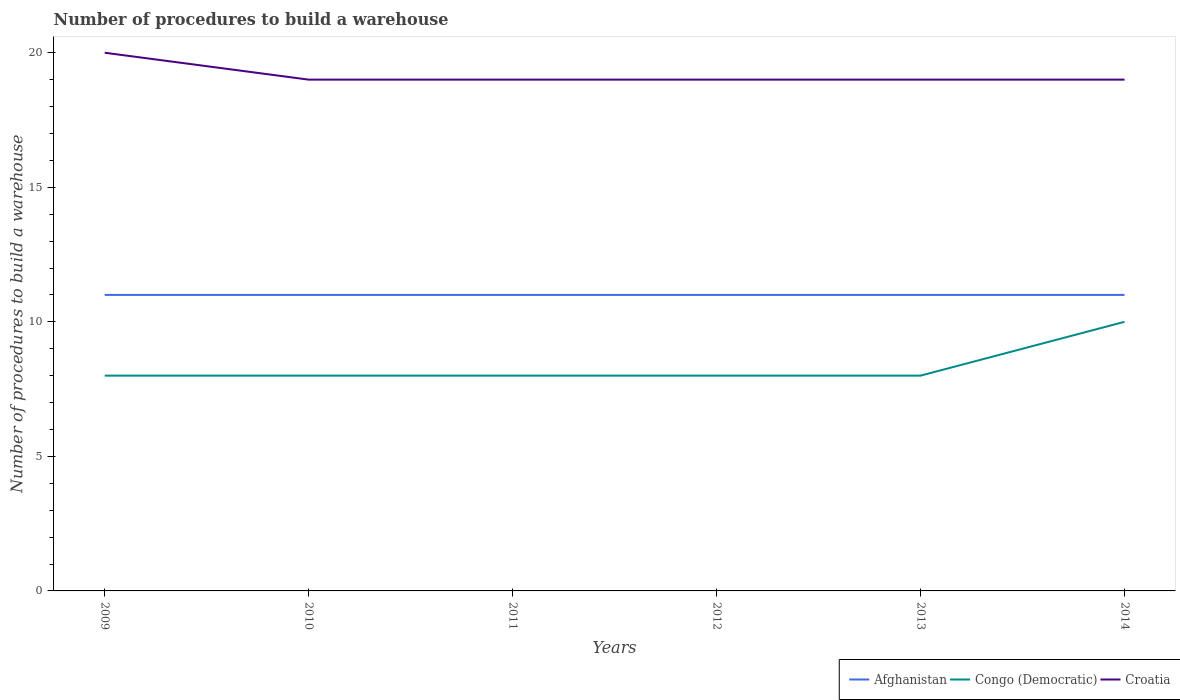How many different coloured lines are there?
Your answer should be compact. 3. Is the number of lines equal to the number of legend labels?
Keep it short and to the point. Yes. Across all years, what is the maximum number of procedures to build a warehouse in in Croatia?
Offer a terse response. 19. What is the difference between the highest and the second highest number of procedures to build a warehouse in in Croatia?
Your answer should be very brief. 1. How many lines are there?
Provide a succinct answer. 3. Where does the legend appear in the graph?
Offer a very short reply. Bottom right. How are the legend labels stacked?
Your answer should be compact. Horizontal. What is the title of the graph?
Give a very brief answer. Number of procedures to build a warehouse. Does "Low income" appear as one of the legend labels in the graph?
Offer a terse response. No. What is the label or title of the Y-axis?
Provide a short and direct response. Number of procedures to build a warehouse. What is the Number of procedures to build a warehouse of Afghanistan in 2009?
Give a very brief answer. 11. What is the Number of procedures to build a warehouse of Congo (Democratic) in 2009?
Give a very brief answer. 8. What is the Number of procedures to build a warehouse in Croatia in 2009?
Keep it short and to the point. 20. What is the Number of procedures to build a warehouse in Afghanistan in 2010?
Offer a very short reply. 11. What is the Number of procedures to build a warehouse in Croatia in 2010?
Make the answer very short. 19. What is the Number of procedures to build a warehouse in Croatia in 2011?
Provide a short and direct response. 19. What is the Number of procedures to build a warehouse of Afghanistan in 2012?
Give a very brief answer. 11. What is the Number of procedures to build a warehouse in Croatia in 2013?
Keep it short and to the point. 19. Across all years, what is the minimum Number of procedures to build a warehouse of Afghanistan?
Your answer should be compact. 11. Across all years, what is the minimum Number of procedures to build a warehouse of Congo (Democratic)?
Give a very brief answer. 8. What is the total Number of procedures to build a warehouse of Congo (Democratic) in the graph?
Your answer should be very brief. 50. What is the total Number of procedures to build a warehouse of Croatia in the graph?
Make the answer very short. 115. What is the difference between the Number of procedures to build a warehouse in Afghanistan in 2009 and that in 2010?
Your response must be concise. 0. What is the difference between the Number of procedures to build a warehouse of Afghanistan in 2009 and that in 2011?
Your answer should be very brief. 0. What is the difference between the Number of procedures to build a warehouse in Congo (Democratic) in 2009 and that in 2011?
Offer a very short reply. 0. What is the difference between the Number of procedures to build a warehouse in Croatia in 2009 and that in 2011?
Keep it short and to the point. 1. What is the difference between the Number of procedures to build a warehouse of Afghanistan in 2009 and that in 2012?
Your answer should be very brief. 0. What is the difference between the Number of procedures to build a warehouse of Afghanistan in 2009 and that in 2013?
Your answer should be very brief. 0. What is the difference between the Number of procedures to build a warehouse in Afghanistan in 2009 and that in 2014?
Your answer should be compact. 0. What is the difference between the Number of procedures to build a warehouse in Afghanistan in 2010 and that in 2012?
Give a very brief answer. 0. What is the difference between the Number of procedures to build a warehouse of Croatia in 2010 and that in 2013?
Give a very brief answer. 0. What is the difference between the Number of procedures to build a warehouse in Congo (Democratic) in 2010 and that in 2014?
Provide a short and direct response. -2. What is the difference between the Number of procedures to build a warehouse of Croatia in 2010 and that in 2014?
Your answer should be very brief. 0. What is the difference between the Number of procedures to build a warehouse in Croatia in 2011 and that in 2012?
Your response must be concise. 0. What is the difference between the Number of procedures to build a warehouse of Afghanistan in 2011 and that in 2014?
Your response must be concise. 0. What is the difference between the Number of procedures to build a warehouse in Afghanistan in 2012 and that in 2013?
Your answer should be compact. 0. What is the difference between the Number of procedures to build a warehouse in Congo (Democratic) in 2012 and that in 2013?
Your response must be concise. 0. What is the difference between the Number of procedures to build a warehouse of Afghanistan in 2013 and that in 2014?
Provide a succinct answer. 0. What is the difference between the Number of procedures to build a warehouse of Congo (Democratic) in 2013 and that in 2014?
Your answer should be compact. -2. What is the difference between the Number of procedures to build a warehouse of Afghanistan in 2009 and the Number of procedures to build a warehouse of Congo (Democratic) in 2010?
Offer a very short reply. 3. What is the difference between the Number of procedures to build a warehouse in Afghanistan in 2009 and the Number of procedures to build a warehouse in Croatia in 2010?
Offer a very short reply. -8. What is the difference between the Number of procedures to build a warehouse of Afghanistan in 2009 and the Number of procedures to build a warehouse of Croatia in 2011?
Your answer should be compact. -8. What is the difference between the Number of procedures to build a warehouse of Congo (Democratic) in 2009 and the Number of procedures to build a warehouse of Croatia in 2011?
Your answer should be compact. -11. What is the difference between the Number of procedures to build a warehouse in Afghanistan in 2009 and the Number of procedures to build a warehouse in Congo (Democratic) in 2013?
Provide a short and direct response. 3. What is the difference between the Number of procedures to build a warehouse of Afghanistan in 2009 and the Number of procedures to build a warehouse of Croatia in 2013?
Give a very brief answer. -8. What is the difference between the Number of procedures to build a warehouse in Afghanistan in 2010 and the Number of procedures to build a warehouse in Congo (Democratic) in 2011?
Provide a short and direct response. 3. What is the difference between the Number of procedures to build a warehouse in Afghanistan in 2010 and the Number of procedures to build a warehouse in Congo (Democratic) in 2012?
Provide a succinct answer. 3. What is the difference between the Number of procedures to build a warehouse of Afghanistan in 2010 and the Number of procedures to build a warehouse of Croatia in 2012?
Your answer should be compact. -8. What is the difference between the Number of procedures to build a warehouse in Afghanistan in 2010 and the Number of procedures to build a warehouse in Croatia in 2013?
Provide a succinct answer. -8. What is the difference between the Number of procedures to build a warehouse of Afghanistan in 2010 and the Number of procedures to build a warehouse of Congo (Democratic) in 2014?
Keep it short and to the point. 1. What is the difference between the Number of procedures to build a warehouse of Afghanistan in 2010 and the Number of procedures to build a warehouse of Croatia in 2014?
Your answer should be compact. -8. What is the difference between the Number of procedures to build a warehouse in Congo (Democratic) in 2010 and the Number of procedures to build a warehouse in Croatia in 2014?
Offer a very short reply. -11. What is the difference between the Number of procedures to build a warehouse in Congo (Democratic) in 2011 and the Number of procedures to build a warehouse in Croatia in 2012?
Give a very brief answer. -11. What is the difference between the Number of procedures to build a warehouse of Afghanistan in 2011 and the Number of procedures to build a warehouse of Croatia in 2013?
Provide a short and direct response. -8. What is the difference between the Number of procedures to build a warehouse of Congo (Democratic) in 2011 and the Number of procedures to build a warehouse of Croatia in 2013?
Make the answer very short. -11. What is the difference between the Number of procedures to build a warehouse of Congo (Democratic) in 2011 and the Number of procedures to build a warehouse of Croatia in 2014?
Offer a terse response. -11. What is the difference between the Number of procedures to build a warehouse of Afghanistan in 2012 and the Number of procedures to build a warehouse of Congo (Democratic) in 2013?
Keep it short and to the point. 3. What is the difference between the Number of procedures to build a warehouse of Afghanistan in 2012 and the Number of procedures to build a warehouse of Croatia in 2013?
Offer a very short reply. -8. What is the difference between the Number of procedures to build a warehouse in Congo (Democratic) in 2012 and the Number of procedures to build a warehouse in Croatia in 2013?
Ensure brevity in your answer.  -11. What is the difference between the Number of procedures to build a warehouse of Afghanistan in 2012 and the Number of procedures to build a warehouse of Congo (Democratic) in 2014?
Offer a terse response. 1. What is the difference between the Number of procedures to build a warehouse in Afghanistan in 2012 and the Number of procedures to build a warehouse in Croatia in 2014?
Ensure brevity in your answer.  -8. What is the difference between the Number of procedures to build a warehouse of Afghanistan in 2013 and the Number of procedures to build a warehouse of Congo (Democratic) in 2014?
Offer a very short reply. 1. What is the average Number of procedures to build a warehouse of Congo (Democratic) per year?
Ensure brevity in your answer.  8.33. What is the average Number of procedures to build a warehouse in Croatia per year?
Your response must be concise. 19.17. In the year 2009, what is the difference between the Number of procedures to build a warehouse in Afghanistan and Number of procedures to build a warehouse in Congo (Democratic)?
Provide a succinct answer. 3. In the year 2009, what is the difference between the Number of procedures to build a warehouse of Congo (Democratic) and Number of procedures to build a warehouse of Croatia?
Make the answer very short. -12. In the year 2010, what is the difference between the Number of procedures to build a warehouse in Afghanistan and Number of procedures to build a warehouse in Croatia?
Make the answer very short. -8. In the year 2011, what is the difference between the Number of procedures to build a warehouse of Afghanistan and Number of procedures to build a warehouse of Congo (Democratic)?
Keep it short and to the point. 3. In the year 2011, what is the difference between the Number of procedures to build a warehouse in Afghanistan and Number of procedures to build a warehouse in Croatia?
Offer a terse response. -8. In the year 2011, what is the difference between the Number of procedures to build a warehouse of Congo (Democratic) and Number of procedures to build a warehouse of Croatia?
Provide a succinct answer. -11. In the year 2012, what is the difference between the Number of procedures to build a warehouse in Afghanistan and Number of procedures to build a warehouse in Congo (Democratic)?
Offer a terse response. 3. In the year 2013, what is the difference between the Number of procedures to build a warehouse of Congo (Democratic) and Number of procedures to build a warehouse of Croatia?
Provide a succinct answer. -11. In the year 2014, what is the difference between the Number of procedures to build a warehouse in Congo (Democratic) and Number of procedures to build a warehouse in Croatia?
Keep it short and to the point. -9. What is the ratio of the Number of procedures to build a warehouse in Afghanistan in 2009 to that in 2010?
Your answer should be very brief. 1. What is the ratio of the Number of procedures to build a warehouse of Croatia in 2009 to that in 2010?
Your answer should be compact. 1.05. What is the ratio of the Number of procedures to build a warehouse of Croatia in 2009 to that in 2011?
Offer a terse response. 1.05. What is the ratio of the Number of procedures to build a warehouse in Congo (Democratic) in 2009 to that in 2012?
Your answer should be very brief. 1. What is the ratio of the Number of procedures to build a warehouse of Croatia in 2009 to that in 2012?
Provide a short and direct response. 1.05. What is the ratio of the Number of procedures to build a warehouse in Afghanistan in 2009 to that in 2013?
Give a very brief answer. 1. What is the ratio of the Number of procedures to build a warehouse of Congo (Democratic) in 2009 to that in 2013?
Offer a terse response. 1. What is the ratio of the Number of procedures to build a warehouse in Croatia in 2009 to that in 2013?
Your answer should be very brief. 1.05. What is the ratio of the Number of procedures to build a warehouse in Croatia in 2009 to that in 2014?
Make the answer very short. 1.05. What is the ratio of the Number of procedures to build a warehouse in Afghanistan in 2010 to that in 2011?
Your response must be concise. 1. What is the ratio of the Number of procedures to build a warehouse of Congo (Democratic) in 2010 to that in 2011?
Provide a succinct answer. 1. What is the ratio of the Number of procedures to build a warehouse in Croatia in 2010 to that in 2012?
Provide a short and direct response. 1. What is the ratio of the Number of procedures to build a warehouse in Congo (Democratic) in 2010 to that in 2014?
Make the answer very short. 0.8. What is the ratio of the Number of procedures to build a warehouse in Congo (Democratic) in 2011 to that in 2012?
Provide a short and direct response. 1. What is the ratio of the Number of procedures to build a warehouse in Croatia in 2011 to that in 2012?
Your answer should be very brief. 1. What is the ratio of the Number of procedures to build a warehouse of Congo (Democratic) in 2011 to that in 2013?
Provide a short and direct response. 1. What is the ratio of the Number of procedures to build a warehouse in Afghanistan in 2011 to that in 2014?
Give a very brief answer. 1. What is the ratio of the Number of procedures to build a warehouse of Congo (Democratic) in 2011 to that in 2014?
Offer a very short reply. 0.8. What is the ratio of the Number of procedures to build a warehouse of Croatia in 2011 to that in 2014?
Give a very brief answer. 1. What is the ratio of the Number of procedures to build a warehouse in Afghanistan in 2012 to that in 2013?
Keep it short and to the point. 1. What is the ratio of the Number of procedures to build a warehouse of Congo (Democratic) in 2012 to that in 2013?
Keep it short and to the point. 1. What is the ratio of the Number of procedures to build a warehouse of Croatia in 2012 to that in 2013?
Give a very brief answer. 1. What is the ratio of the Number of procedures to build a warehouse of Congo (Democratic) in 2012 to that in 2014?
Keep it short and to the point. 0.8. What is the ratio of the Number of procedures to build a warehouse of Croatia in 2013 to that in 2014?
Give a very brief answer. 1. What is the difference between the highest and the lowest Number of procedures to build a warehouse of Afghanistan?
Give a very brief answer. 0. 